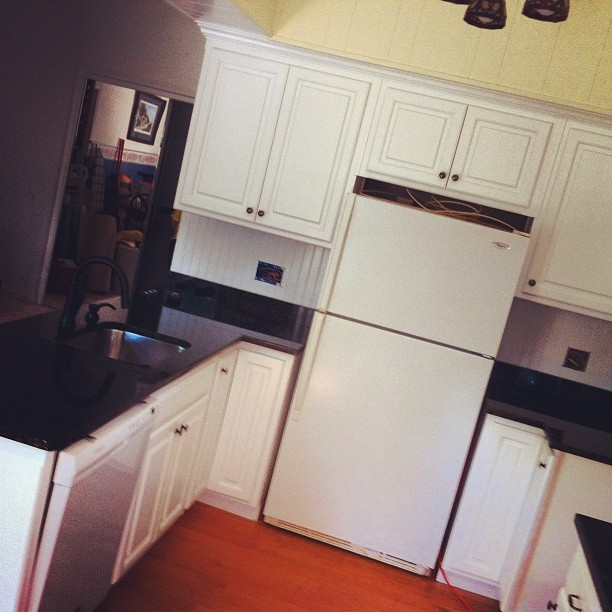Describe the objects in this image and their specific colors. I can see refrigerator in black, lightgray, and darkgray tones, sink in black and gray tones, and couch in black, navy, purple, and brown tones in this image. 